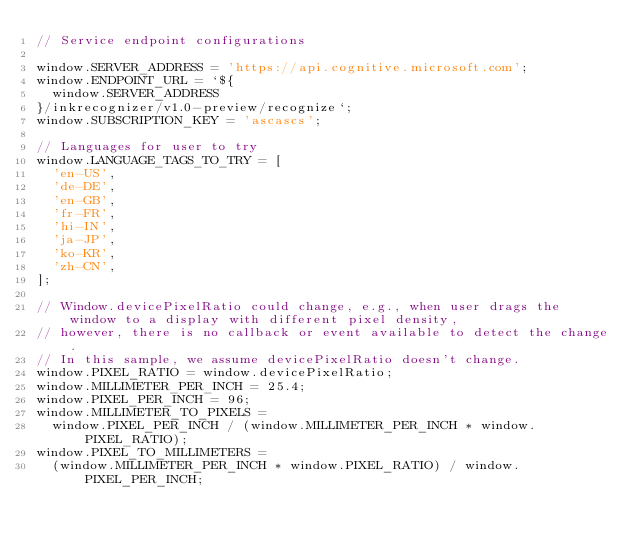<code> <loc_0><loc_0><loc_500><loc_500><_JavaScript_>// Service endpoint configurations

window.SERVER_ADDRESS = 'https://api.cognitive.microsoft.com';
window.ENDPOINT_URL = `${
  window.SERVER_ADDRESS
}/inkrecognizer/v1.0-preview/recognize`;
window.SUBSCRIPTION_KEY = 'ascascs';

// Languages for user to try
window.LANGUAGE_TAGS_TO_TRY = [
  'en-US',
  'de-DE',
  'en-GB',
  'fr-FR',
  'hi-IN',
  'ja-JP',
  'ko-KR',
  'zh-CN',
];

// Window.devicePixelRatio could change, e.g., when user drags the window to a display with different pixel density,
// however, there is no callback or event available to detect the change.
// In this sample, we assume devicePixelRatio doesn't change.
window.PIXEL_RATIO = window.devicePixelRatio;
window.MILLIMETER_PER_INCH = 25.4;
window.PIXEL_PER_INCH = 96;
window.MILLIMETER_TO_PIXELS =
  window.PIXEL_PER_INCH / (window.MILLIMETER_PER_INCH * window.PIXEL_RATIO);
window.PIXEL_TO_MILLIMETERS =
  (window.MILLIMETER_PER_INCH * window.PIXEL_RATIO) / window.PIXEL_PER_INCH;
</code> 